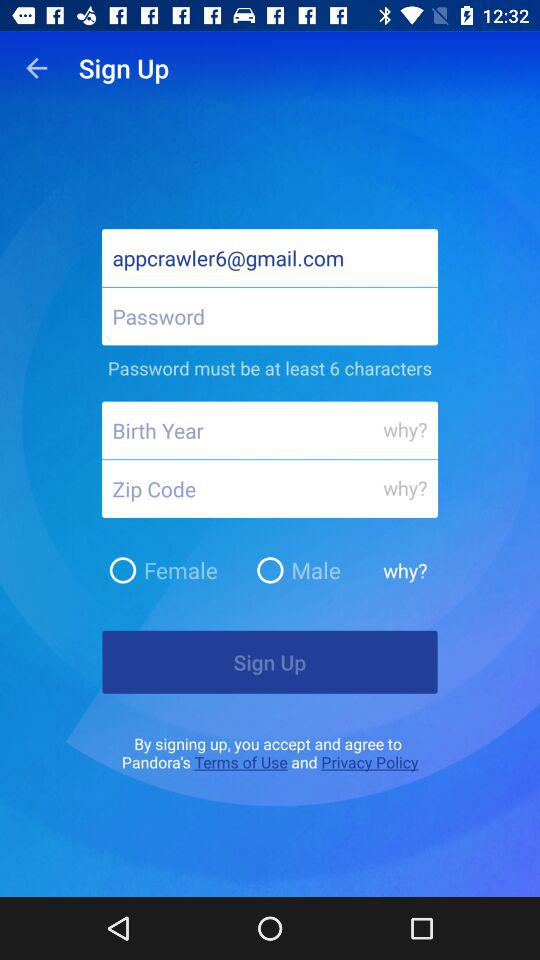What is the email address? The email address is appcrawler6@gmail.com. 